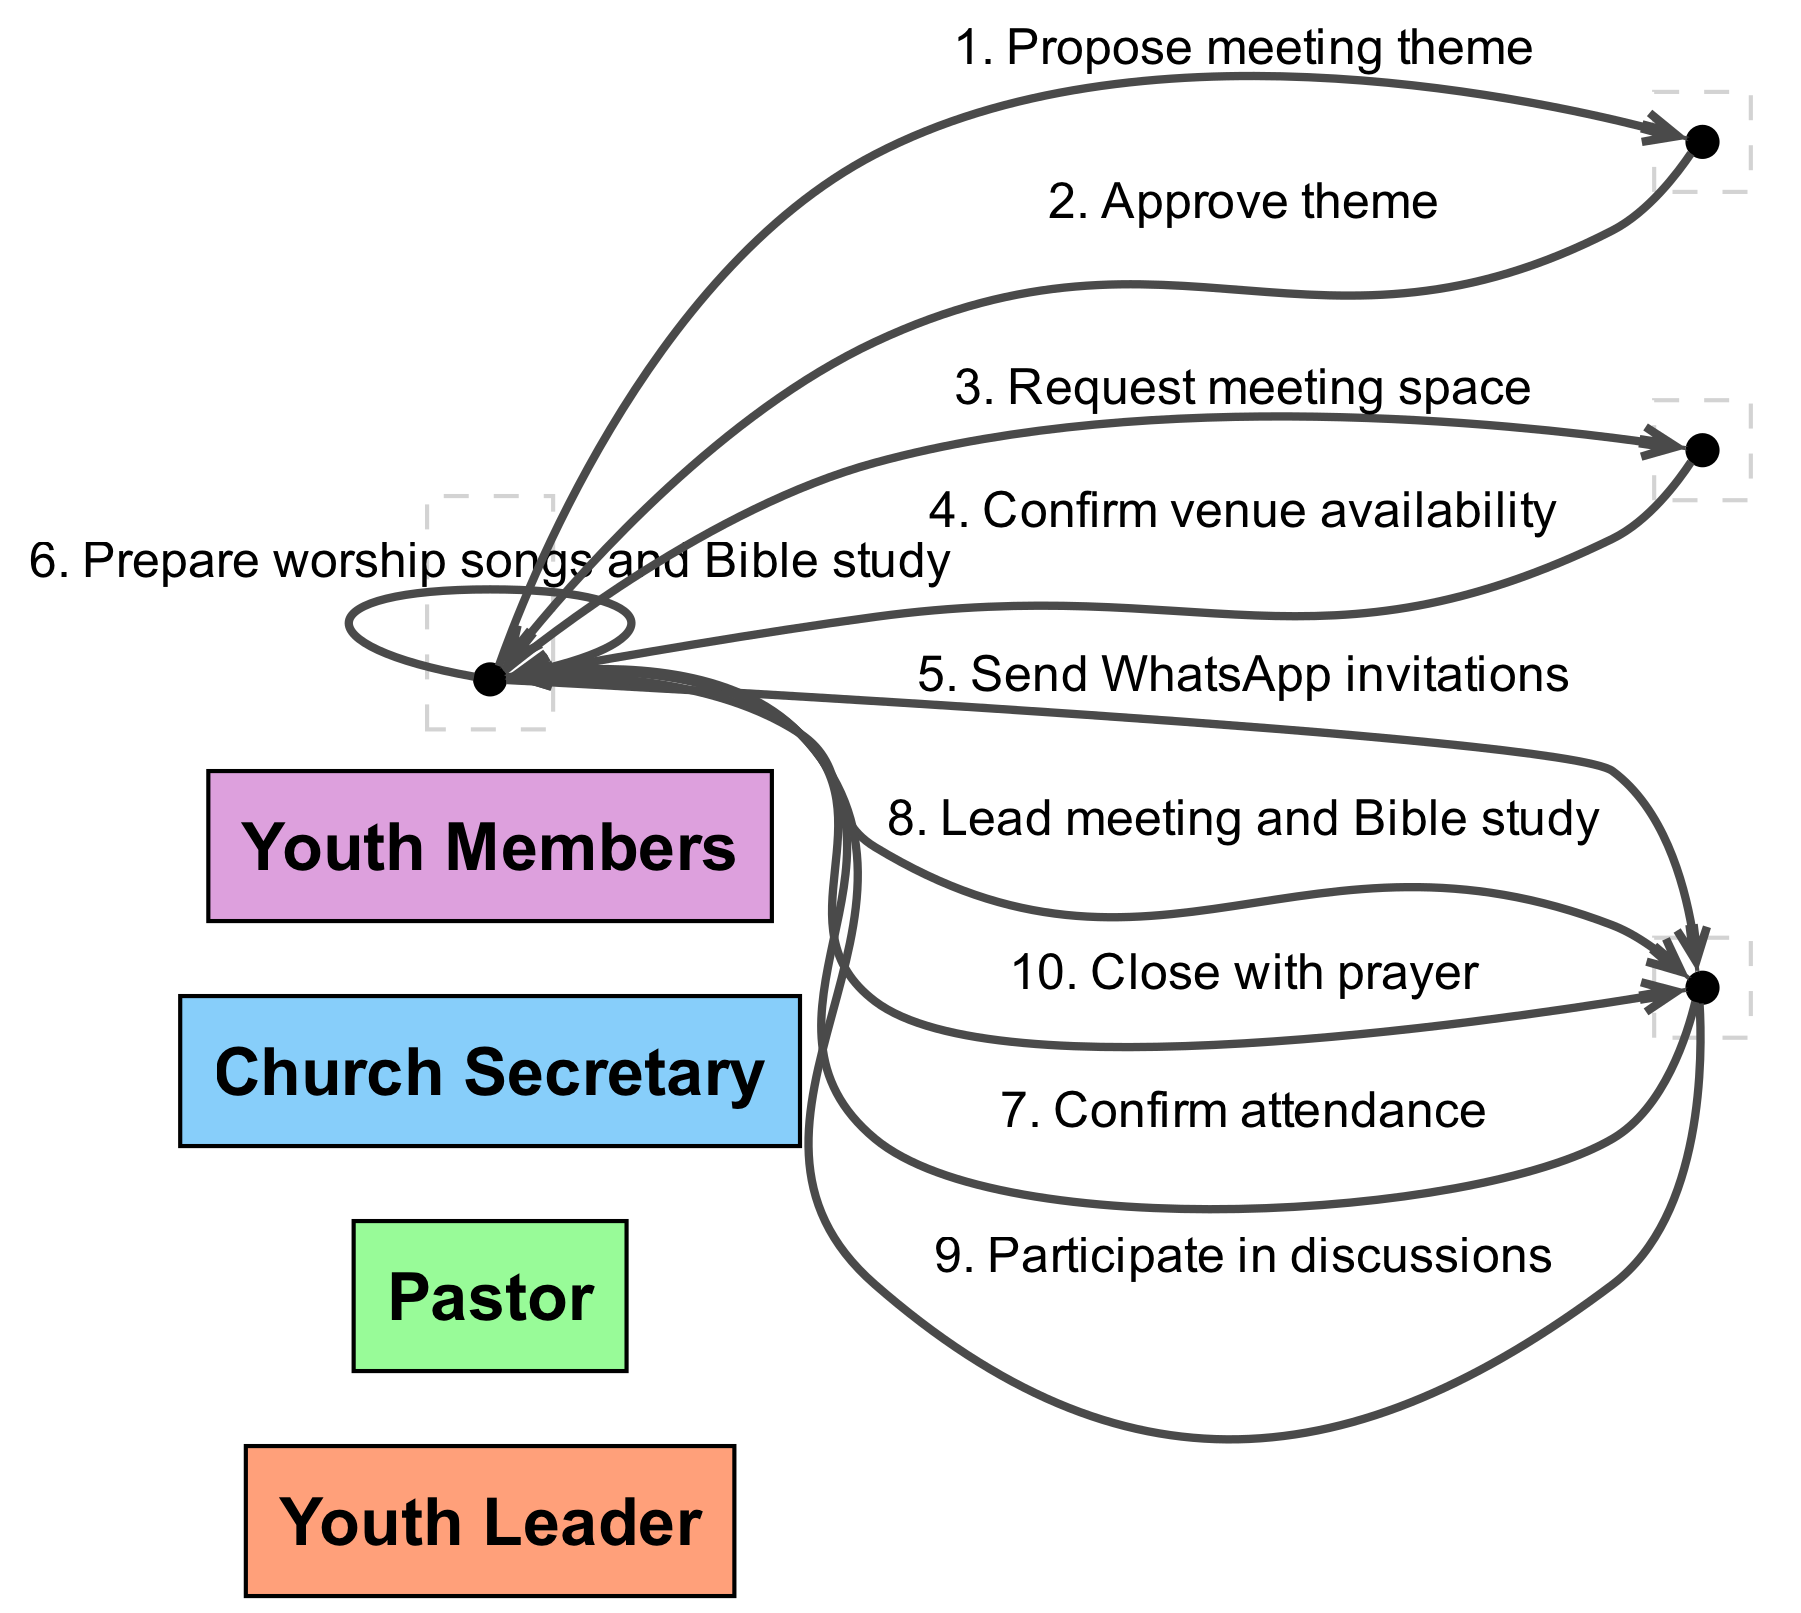What is the first action in the sequence? The first action in the sequence is from the Youth Leader to the Pastor, proposing the meeting theme.
Answer: Propose meeting theme How many actors are involved in the sequence? The diagram lists four actors involved: Youth Leader, Pastor, Church Secretary, and Youth Members.
Answer: Four What action does the Pastor take after receiving a proposal? After receiving the proposal, the Pastor approves the theme suggested by the Youth Leader.
Answer: Approve theme Who confirms the venue availability? The Church Secretary confirms the venue availability after the Youth Leader requests the meeting space.
Answer: Church Secretary What do the Youth Members do after receiving invitations? The Youth Members confirm their attendance after receiving invitations from the Youth Leader.
Answer: Confirm attendance Which actor leads the meeting and Bible study? The Youth Leader is responsible for leading the meeting and Bible study according to the diagram.
Answer: Youth Leader How many actions are initiated by the Youth Leader? The Youth Leader initiates four actions throughout the sequence: proposing a meeting theme, requesting meeting space, sending invitations, and leading the meeting.
Answer: Four What is the last action in the sequence? The last action in the sequence is for the Youth Leader to close the meeting with prayer.
Answer: Close with prayer What is the action taken by Youth Members during discussions? The Youth Members participate in discussions following the meeting and Bible study led by the Youth Leader.
Answer: Participate in discussions What role does the Church Secretary play in relation to the Youth Leader? The Church Secretary's role is to confirm the venue availability after the Youth Leader requests it.
Answer: Confirm venue availability 